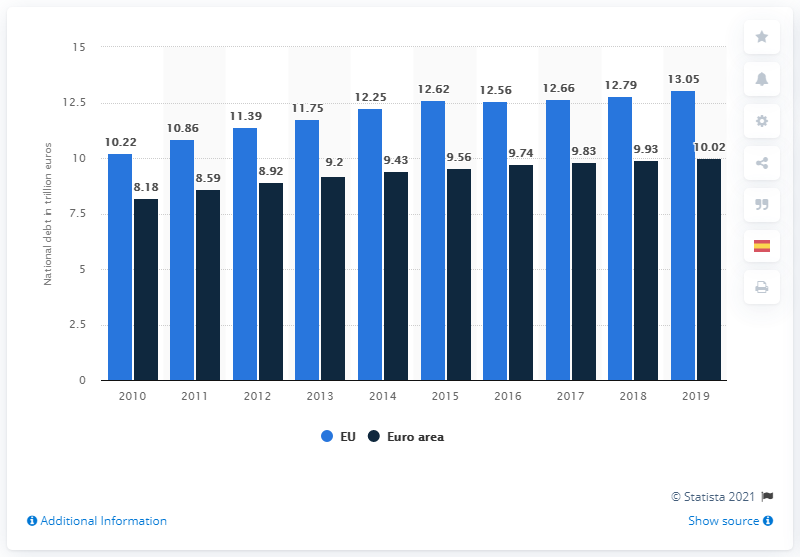Highlight a few significant elements in this photo. The debt of the European Union in 2019 was 13.05. 